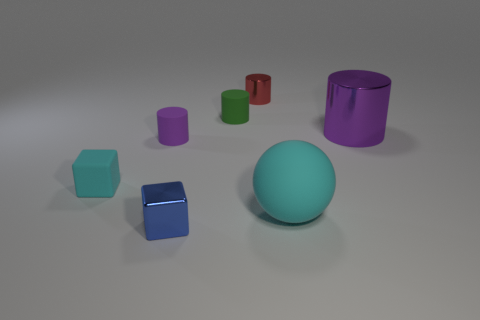Do the tiny block that is in front of the small cyan rubber cube and the cylinder right of the tiny red metallic thing have the same color?
Give a very brief answer. No. What is the shape of the tiny shiny object behind the green matte cylinder?
Provide a succinct answer. Cylinder. The small metal block is what color?
Your answer should be very brief. Blue. The red thing that is made of the same material as the large purple thing is what shape?
Make the answer very short. Cylinder. There is a metallic thing that is in front of the matte cube; is its size the same as the tiny red shiny object?
Make the answer very short. Yes. How many objects are either cyan objects to the right of the small red object or tiny metallic things that are in front of the big cyan matte sphere?
Offer a very short reply. 2. There is a tiny cylinder that is in front of the big purple shiny thing; is its color the same as the big rubber object?
Your answer should be very brief. No. What number of rubber things are either small yellow cylinders or tiny red cylinders?
Offer a terse response. 0. The tiny green rubber object has what shape?
Your response must be concise. Cylinder. Is there anything else that is the same material as the tiny red cylinder?
Make the answer very short. Yes. 